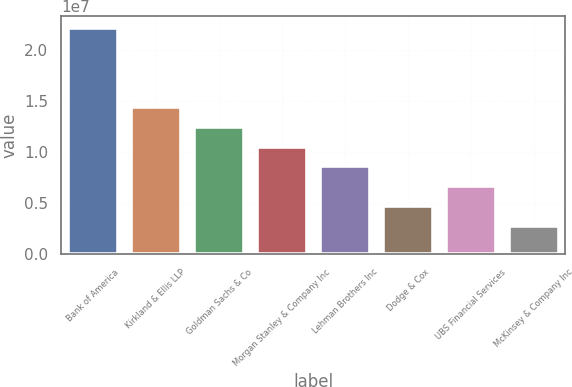Convert chart to OTSL. <chart><loc_0><loc_0><loc_500><loc_500><bar_chart><fcel>Bank of America<fcel>Kirkland & Ellis LLP<fcel>Goldman Sachs & Co<fcel>Morgan Stanley & Company Inc<fcel>Lehman Brothers Inc<fcel>Dodge & Cox<fcel>UBS Financial Services<fcel>McKinsey & Company Inc<nl><fcel>2.2145e+07<fcel>1.4395e+07<fcel>1.24575e+07<fcel>1.052e+07<fcel>8.5825e+06<fcel>4.7075e+06<fcel>6.645e+06<fcel>2.77e+06<nl></chart> 